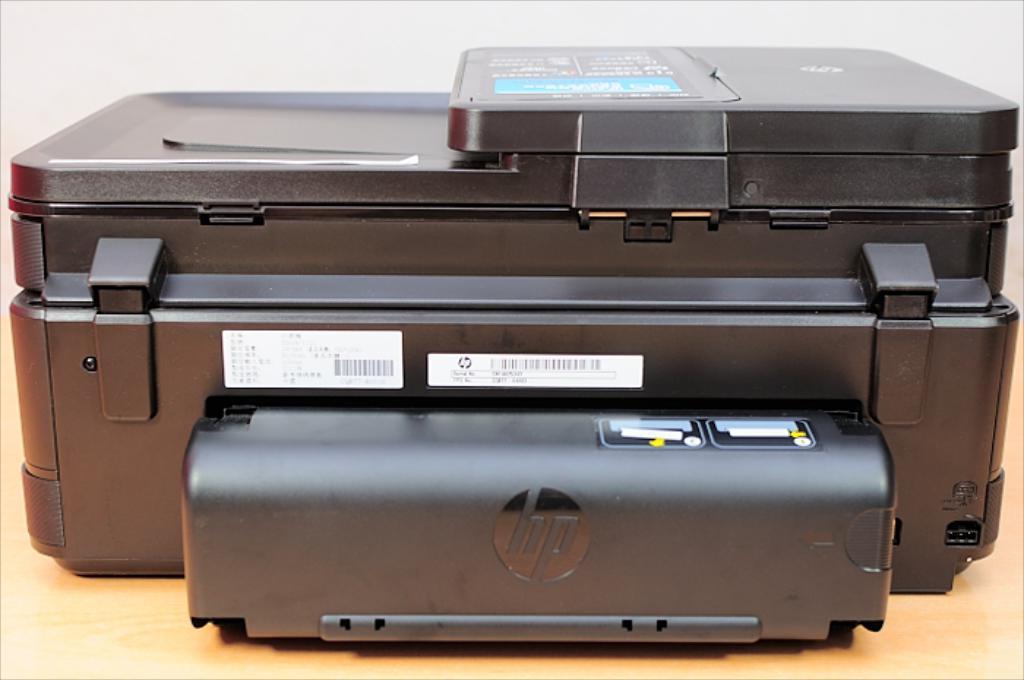Please provide a concise description of this image. In this image we can see a scanner on the wooden surface, also we can see some cards with text on it, and the background is white in color. 